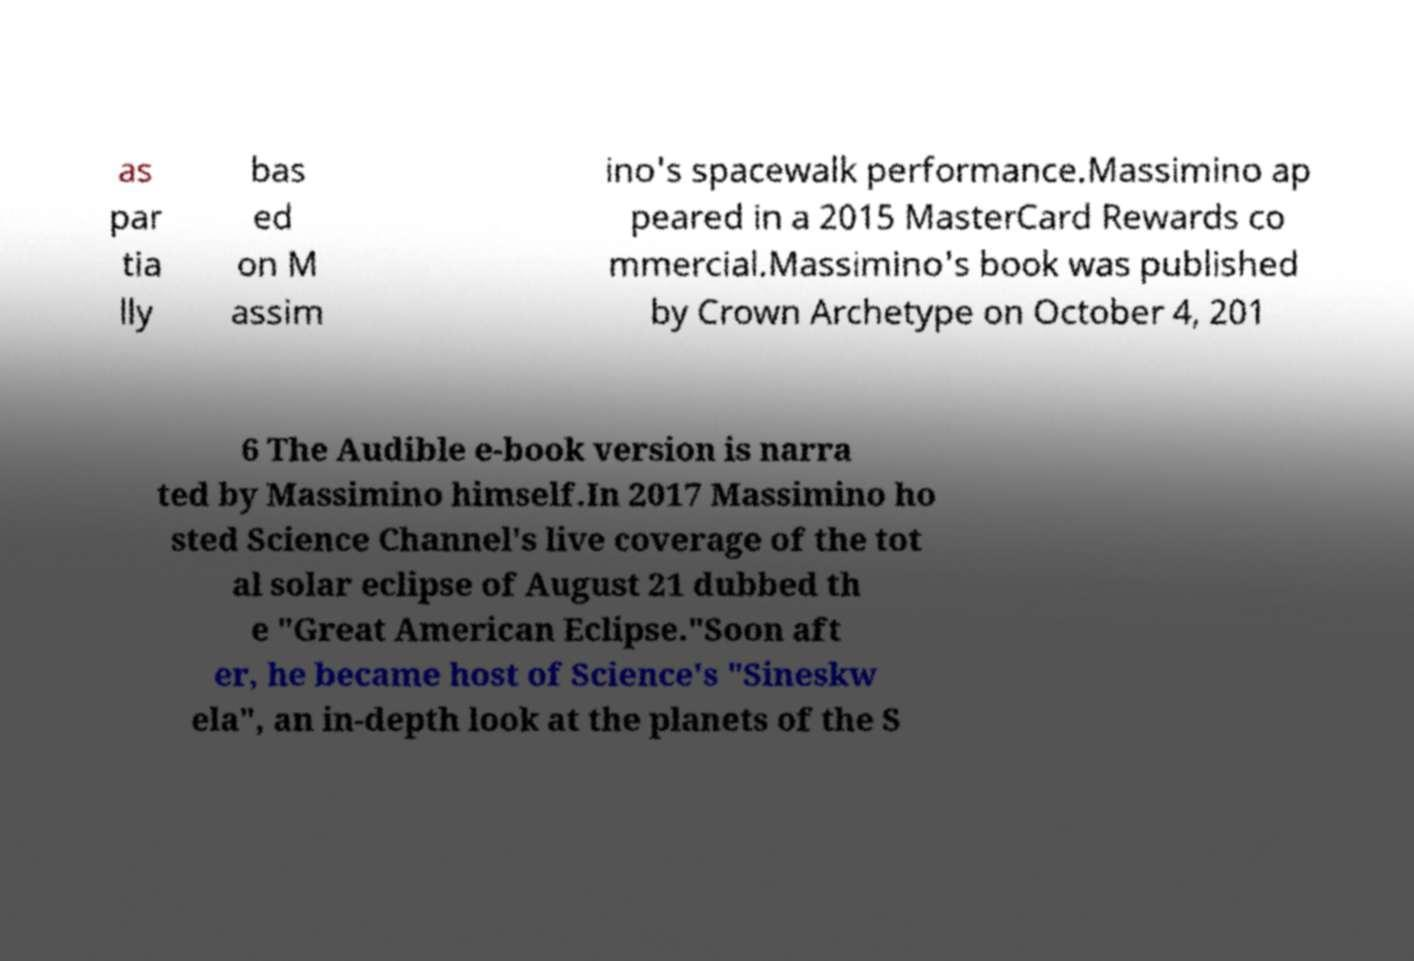Can you accurately transcribe the text from the provided image for me? as par tia lly bas ed on M assim ino's spacewalk performance.Massimino ap peared in a 2015 MasterCard Rewards co mmercial.Massimino's book was published by Crown Archetype on October 4, 201 6 The Audible e-book version is narra ted by Massimino himself.In 2017 Massimino ho sted Science Channel's live coverage of the tot al solar eclipse of August 21 dubbed th e "Great American Eclipse."Soon aft er, he became host of Science's "Sineskw ela", an in-depth look at the planets of the S 